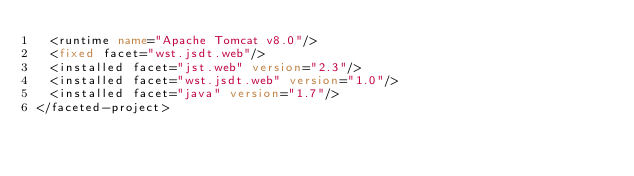Convert code to text. <code><loc_0><loc_0><loc_500><loc_500><_XML_>  <runtime name="Apache Tomcat v8.0"/>
  <fixed facet="wst.jsdt.web"/>
  <installed facet="jst.web" version="2.3"/>
  <installed facet="wst.jsdt.web" version="1.0"/>
  <installed facet="java" version="1.7"/>
</faceted-project>
</code> 